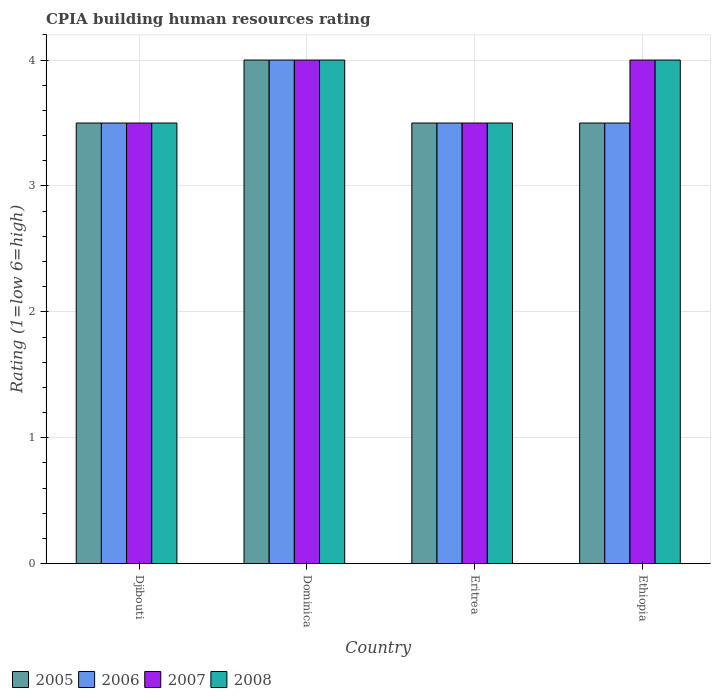Are the number of bars on each tick of the X-axis equal?
Your response must be concise. Yes. How many bars are there on the 1st tick from the left?
Offer a very short reply. 4. How many bars are there on the 4th tick from the right?
Offer a very short reply. 4. What is the label of the 2nd group of bars from the left?
Give a very brief answer. Dominica. In how many cases, is the number of bars for a given country not equal to the number of legend labels?
Provide a short and direct response. 0. Across all countries, what is the maximum CPIA rating in 2005?
Give a very brief answer. 4. In which country was the CPIA rating in 2005 maximum?
Provide a succinct answer. Dominica. In which country was the CPIA rating in 2008 minimum?
Offer a terse response. Djibouti. What is the total CPIA rating in 2008 in the graph?
Provide a succinct answer. 15. What is the average CPIA rating in 2005 per country?
Offer a very short reply. 3.62. Is the difference between the CPIA rating in 2008 in Djibouti and Ethiopia greater than the difference between the CPIA rating in 2005 in Djibouti and Ethiopia?
Provide a short and direct response. No. What is the difference between the highest and the second highest CPIA rating in 2008?
Keep it short and to the point. -0.5. In how many countries, is the CPIA rating in 2008 greater than the average CPIA rating in 2008 taken over all countries?
Offer a very short reply. 2. Is the sum of the CPIA rating in 2005 in Djibouti and Dominica greater than the maximum CPIA rating in 2006 across all countries?
Make the answer very short. Yes. Is it the case that in every country, the sum of the CPIA rating in 2005 and CPIA rating in 2008 is greater than the sum of CPIA rating in 2006 and CPIA rating in 2007?
Keep it short and to the point. No. What does the 2nd bar from the right in Ethiopia represents?
Your answer should be very brief. 2007. How many bars are there?
Your response must be concise. 16. How many countries are there in the graph?
Your response must be concise. 4. What is the difference between two consecutive major ticks on the Y-axis?
Your response must be concise. 1. Are the values on the major ticks of Y-axis written in scientific E-notation?
Ensure brevity in your answer.  No. How many legend labels are there?
Offer a terse response. 4. How are the legend labels stacked?
Provide a succinct answer. Horizontal. What is the title of the graph?
Your response must be concise. CPIA building human resources rating. What is the Rating (1=low 6=high) of 2005 in Djibouti?
Your response must be concise. 3.5. What is the Rating (1=low 6=high) in 2006 in Djibouti?
Your answer should be compact. 3.5. What is the Rating (1=low 6=high) in 2007 in Djibouti?
Provide a succinct answer. 3.5. What is the Rating (1=low 6=high) in 2006 in Dominica?
Keep it short and to the point. 4. What is the Rating (1=low 6=high) of 2008 in Dominica?
Make the answer very short. 4. What is the Rating (1=low 6=high) of 2008 in Eritrea?
Your answer should be compact. 3.5. What is the Rating (1=low 6=high) in 2005 in Ethiopia?
Make the answer very short. 3.5. What is the Rating (1=low 6=high) in 2006 in Ethiopia?
Your answer should be compact. 3.5. What is the Rating (1=low 6=high) of 2008 in Ethiopia?
Offer a very short reply. 4. Across all countries, what is the minimum Rating (1=low 6=high) of 2005?
Your response must be concise. 3.5. Across all countries, what is the minimum Rating (1=low 6=high) of 2008?
Ensure brevity in your answer.  3.5. What is the total Rating (1=low 6=high) in 2005 in the graph?
Ensure brevity in your answer.  14.5. What is the total Rating (1=low 6=high) of 2008 in the graph?
Your response must be concise. 15. What is the difference between the Rating (1=low 6=high) in 2006 in Djibouti and that in Dominica?
Provide a succinct answer. -0.5. What is the difference between the Rating (1=low 6=high) in 2006 in Djibouti and that in Eritrea?
Provide a short and direct response. 0. What is the difference between the Rating (1=low 6=high) in 2007 in Djibouti and that in Eritrea?
Ensure brevity in your answer.  0. What is the difference between the Rating (1=low 6=high) in 2008 in Djibouti and that in Eritrea?
Keep it short and to the point. 0. What is the difference between the Rating (1=low 6=high) of 2005 in Djibouti and that in Ethiopia?
Make the answer very short. 0. What is the difference between the Rating (1=low 6=high) in 2006 in Djibouti and that in Ethiopia?
Offer a terse response. 0. What is the difference between the Rating (1=low 6=high) in 2007 in Djibouti and that in Ethiopia?
Give a very brief answer. -0.5. What is the difference between the Rating (1=low 6=high) of 2008 in Djibouti and that in Ethiopia?
Offer a very short reply. -0.5. What is the difference between the Rating (1=low 6=high) in 2007 in Dominica and that in Eritrea?
Your answer should be very brief. 0.5. What is the difference between the Rating (1=low 6=high) of 2008 in Dominica and that in Eritrea?
Offer a very short reply. 0.5. What is the difference between the Rating (1=low 6=high) in 2006 in Dominica and that in Ethiopia?
Offer a very short reply. 0.5. What is the difference between the Rating (1=low 6=high) in 2007 in Dominica and that in Ethiopia?
Keep it short and to the point. 0. What is the difference between the Rating (1=low 6=high) in 2005 in Eritrea and that in Ethiopia?
Keep it short and to the point. 0. What is the difference between the Rating (1=low 6=high) in 2006 in Eritrea and that in Ethiopia?
Offer a terse response. 0. What is the difference between the Rating (1=low 6=high) of 2008 in Eritrea and that in Ethiopia?
Ensure brevity in your answer.  -0.5. What is the difference between the Rating (1=low 6=high) in 2005 in Djibouti and the Rating (1=low 6=high) in 2006 in Dominica?
Your response must be concise. -0.5. What is the difference between the Rating (1=low 6=high) of 2005 in Djibouti and the Rating (1=low 6=high) of 2008 in Dominica?
Offer a very short reply. -0.5. What is the difference between the Rating (1=low 6=high) of 2006 in Djibouti and the Rating (1=low 6=high) of 2008 in Dominica?
Your response must be concise. -0.5. What is the difference between the Rating (1=low 6=high) of 2005 in Djibouti and the Rating (1=low 6=high) of 2008 in Eritrea?
Make the answer very short. 0. What is the difference between the Rating (1=low 6=high) of 2006 in Djibouti and the Rating (1=low 6=high) of 2008 in Eritrea?
Keep it short and to the point. 0. What is the difference between the Rating (1=low 6=high) of 2005 in Djibouti and the Rating (1=low 6=high) of 2006 in Ethiopia?
Keep it short and to the point. 0. What is the difference between the Rating (1=low 6=high) of 2005 in Djibouti and the Rating (1=low 6=high) of 2008 in Ethiopia?
Make the answer very short. -0.5. What is the difference between the Rating (1=low 6=high) of 2006 in Djibouti and the Rating (1=low 6=high) of 2007 in Ethiopia?
Ensure brevity in your answer.  -0.5. What is the difference between the Rating (1=low 6=high) of 2006 in Djibouti and the Rating (1=low 6=high) of 2008 in Ethiopia?
Offer a terse response. -0.5. What is the difference between the Rating (1=low 6=high) of 2005 in Dominica and the Rating (1=low 6=high) of 2008 in Eritrea?
Your answer should be very brief. 0.5. What is the difference between the Rating (1=low 6=high) in 2006 in Dominica and the Rating (1=low 6=high) in 2007 in Eritrea?
Ensure brevity in your answer.  0.5. What is the difference between the Rating (1=low 6=high) of 2006 in Dominica and the Rating (1=low 6=high) of 2008 in Ethiopia?
Your answer should be very brief. 0. What is the difference between the Rating (1=low 6=high) of 2005 in Eritrea and the Rating (1=low 6=high) of 2007 in Ethiopia?
Your answer should be very brief. -0.5. What is the average Rating (1=low 6=high) of 2005 per country?
Your answer should be very brief. 3.62. What is the average Rating (1=low 6=high) in 2006 per country?
Give a very brief answer. 3.62. What is the average Rating (1=low 6=high) of 2007 per country?
Keep it short and to the point. 3.75. What is the average Rating (1=low 6=high) of 2008 per country?
Make the answer very short. 3.75. What is the difference between the Rating (1=low 6=high) in 2005 and Rating (1=low 6=high) in 2006 in Djibouti?
Ensure brevity in your answer.  0. What is the difference between the Rating (1=low 6=high) of 2005 and Rating (1=low 6=high) of 2008 in Dominica?
Your answer should be very brief. 0. What is the difference between the Rating (1=low 6=high) in 2006 and Rating (1=low 6=high) in 2007 in Dominica?
Ensure brevity in your answer.  0. What is the difference between the Rating (1=low 6=high) in 2005 and Rating (1=low 6=high) in 2006 in Eritrea?
Your answer should be compact. 0. What is the difference between the Rating (1=low 6=high) of 2005 and Rating (1=low 6=high) of 2007 in Eritrea?
Your response must be concise. 0. What is the difference between the Rating (1=low 6=high) in 2006 and Rating (1=low 6=high) in 2007 in Eritrea?
Offer a terse response. 0. What is the difference between the Rating (1=low 6=high) in 2006 and Rating (1=low 6=high) in 2008 in Eritrea?
Offer a very short reply. 0. What is the difference between the Rating (1=low 6=high) in 2007 and Rating (1=low 6=high) in 2008 in Eritrea?
Make the answer very short. 0. What is the difference between the Rating (1=low 6=high) in 2005 and Rating (1=low 6=high) in 2006 in Ethiopia?
Ensure brevity in your answer.  0. What is the difference between the Rating (1=low 6=high) of 2005 and Rating (1=low 6=high) of 2008 in Ethiopia?
Give a very brief answer. -0.5. What is the difference between the Rating (1=low 6=high) of 2006 and Rating (1=low 6=high) of 2007 in Ethiopia?
Provide a short and direct response. -0.5. What is the ratio of the Rating (1=low 6=high) in 2005 in Djibouti to that in Dominica?
Keep it short and to the point. 0.88. What is the ratio of the Rating (1=low 6=high) in 2007 in Djibouti to that in Dominica?
Your answer should be very brief. 0.88. What is the ratio of the Rating (1=low 6=high) in 2006 in Djibouti to that in Eritrea?
Your answer should be compact. 1. What is the ratio of the Rating (1=low 6=high) in 2007 in Djibouti to that in Eritrea?
Your response must be concise. 1. What is the ratio of the Rating (1=low 6=high) in 2008 in Djibouti to that in Eritrea?
Keep it short and to the point. 1. What is the ratio of the Rating (1=low 6=high) in 2006 in Dominica to that in Eritrea?
Your answer should be compact. 1.14. What is the ratio of the Rating (1=low 6=high) in 2007 in Dominica to that in Ethiopia?
Provide a short and direct response. 1. What is the ratio of the Rating (1=low 6=high) of 2008 in Dominica to that in Ethiopia?
Give a very brief answer. 1. What is the ratio of the Rating (1=low 6=high) of 2006 in Eritrea to that in Ethiopia?
Offer a very short reply. 1. What is the ratio of the Rating (1=low 6=high) in 2007 in Eritrea to that in Ethiopia?
Provide a succinct answer. 0.88. What is the difference between the highest and the second highest Rating (1=low 6=high) of 2005?
Provide a succinct answer. 0.5. What is the difference between the highest and the second highest Rating (1=low 6=high) in 2006?
Make the answer very short. 0.5. What is the difference between the highest and the second highest Rating (1=low 6=high) of 2008?
Make the answer very short. 0. What is the difference between the highest and the lowest Rating (1=low 6=high) of 2005?
Make the answer very short. 0.5. 